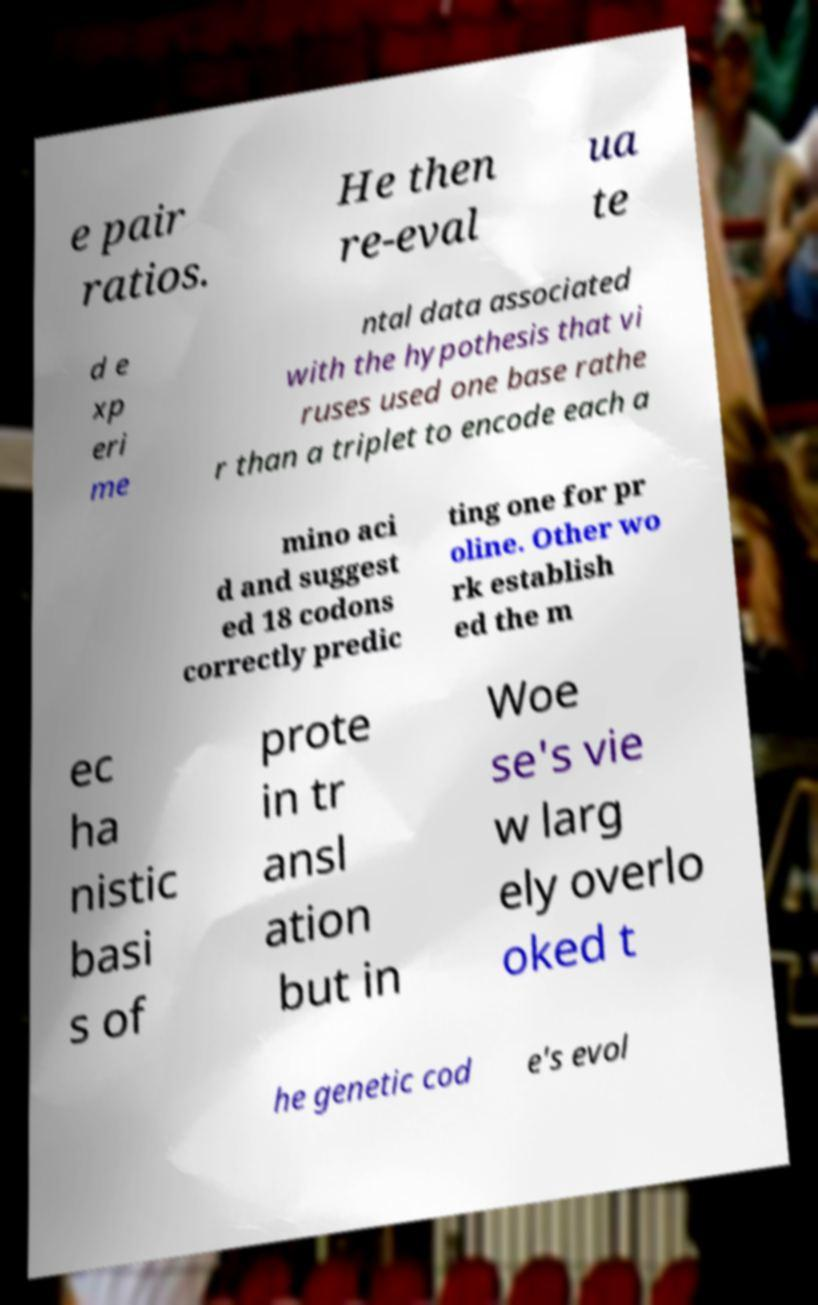Please read and relay the text visible in this image. What does it say? e pair ratios. He then re-eval ua te d e xp eri me ntal data associated with the hypothesis that vi ruses used one base rathe r than a triplet to encode each a mino aci d and suggest ed 18 codons correctly predic ting one for pr oline. Other wo rk establish ed the m ec ha nistic basi s of prote in tr ansl ation but in Woe se's vie w larg ely overlo oked t he genetic cod e's evol 